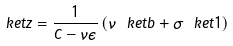Convert formula to latex. <formula><loc_0><loc_0><loc_500><loc_500>\ k e t { z } = \frac { 1 } { \hat { C } - \nu \epsilon } \left ( \nu \ k e t { b } + \sigma \ k e t { 1 } \right )</formula> 